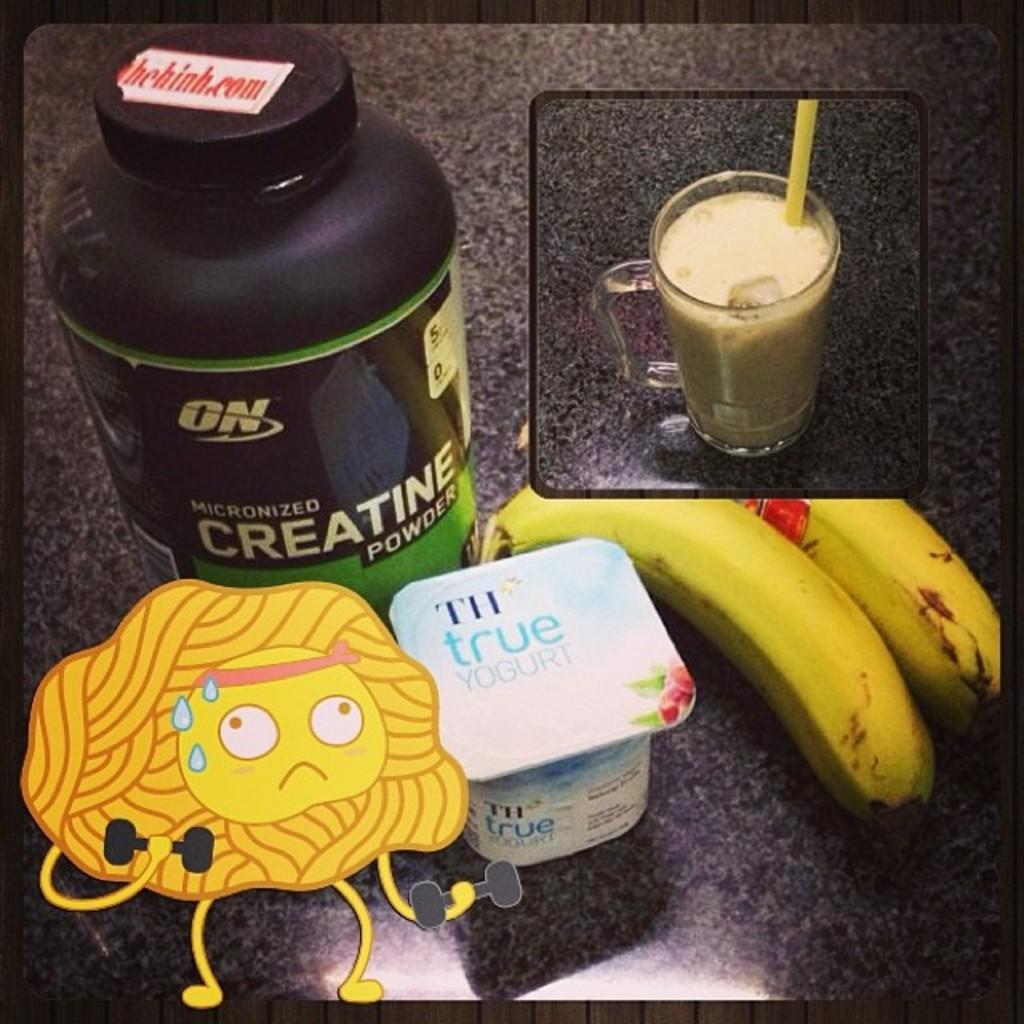What type of fruit is visible in the image? There are bananas in the image. What is the container for a liquid in the image? There is a glass in the image. What can be seen on a surface in the image? There are other objects on a surface in the image. What type of visual entertainment is present in the image? There is a cartoon in the image. What type of cannon is used to maintain the rhythm in the image? There is no cannon or rhythm present in the image. How does the transport system function in the image? There is no transport system present in the image. 